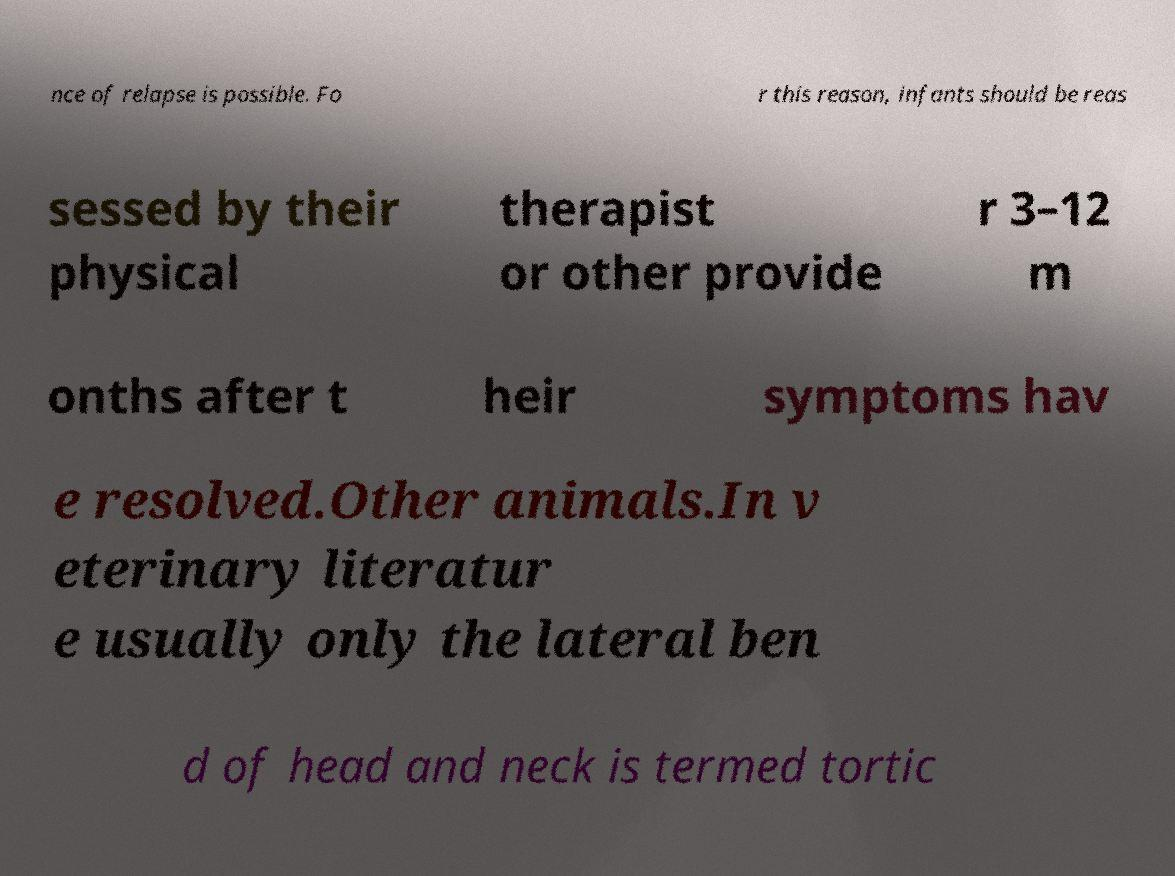Can you accurately transcribe the text from the provided image for me? nce of relapse is possible. Fo r this reason, infants should be reas sessed by their physical therapist or other provide r 3–12 m onths after t heir symptoms hav e resolved.Other animals.In v eterinary literatur e usually only the lateral ben d of head and neck is termed tortic 